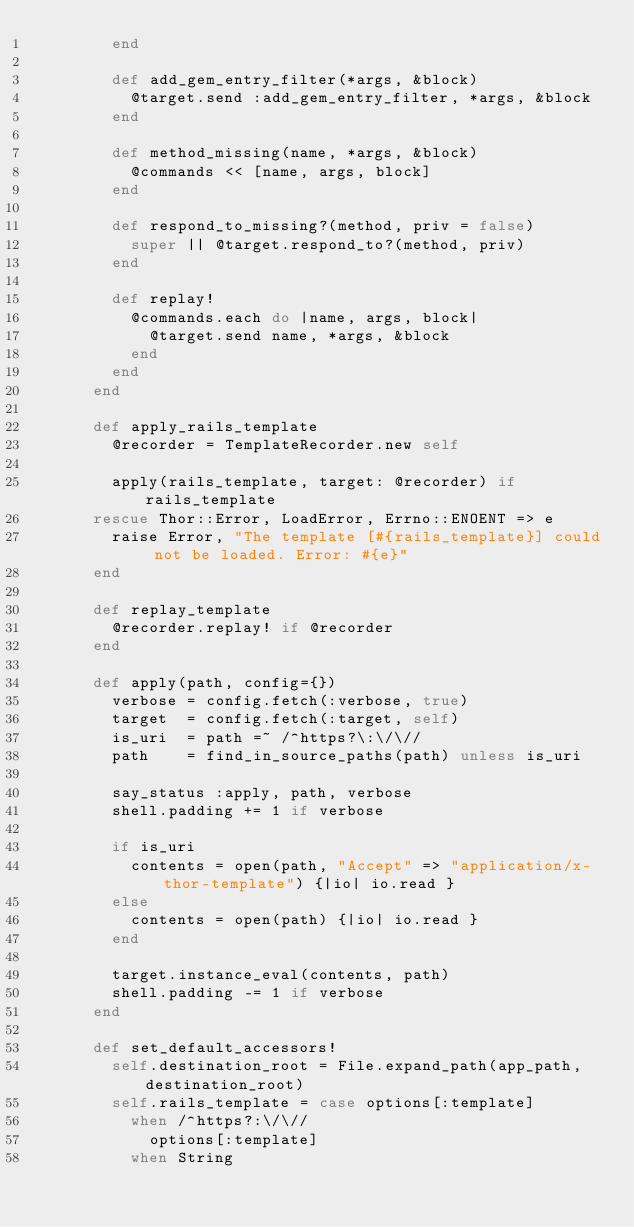<code> <loc_0><loc_0><loc_500><loc_500><_Ruby_>        end

        def add_gem_entry_filter(*args, &block)
          @target.send :add_gem_entry_filter, *args, &block
        end

        def method_missing(name, *args, &block)
          @commands << [name, args, block]
        end

        def respond_to_missing?(method, priv = false)
          super || @target.respond_to?(method, priv)
        end

        def replay!
          @commands.each do |name, args, block|
            @target.send name, *args, &block
          end
        end
      end

      def apply_rails_template
        @recorder = TemplateRecorder.new self

        apply(rails_template, target: @recorder) if rails_template
      rescue Thor::Error, LoadError, Errno::ENOENT => e
        raise Error, "The template [#{rails_template}] could not be loaded. Error: #{e}"
      end

      def replay_template
        @recorder.replay! if @recorder
      end

      def apply(path, config={})
        verbose = config.fetch(:verbose, true)
        target  = config.fetch(:target, self)
        is_uri  = path =~ /^https?\:\/\//
        path    = find_in_source_paths(path) unless is_uri

        say_status :apply, path, verbose
        shell.padding += 1 if verbose

        if is_uri
          contents = open(path, "Accept" => "application/x-thor-template") {|io| io.read }
        else
          contents = open(path) {|io| io.read }
        end

        target.instance_eval(contents, path)
        shell.padding -= 1 if verbose
      end

      def set_default_accessors!
        self.destination_root = File.expand_path(app_path, destination_root)
        self.rails_template = case options[:template]
          when /^https?:\/\//
            options[:template]
          when String</code> 